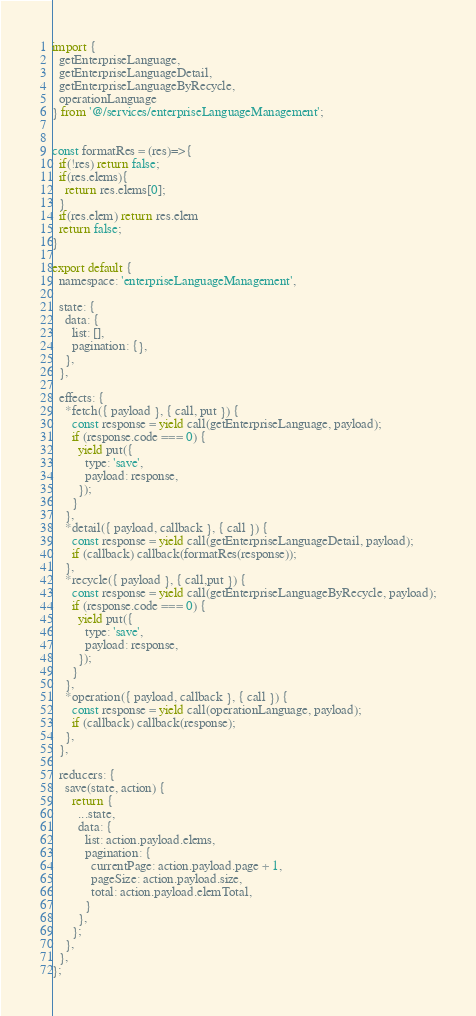<code> <loc_0><loc_0><loc_500><loc_500><_JavaScript_>import {
  getEnterpriseLanguage,
  getEnterpriseLanguageDetail,
  getEnterpriseLanguageByRecycle,
  operationLanguage
} from '@/services/enterpriseLanguageManagement';


const formatRes = (res)=>{
  if(!res) return false;
  if(res.elems){
    return res.elems[0];
  }
  if(res.elem) return res.elem
  return false;
}

export default {
  namespace: 'enterpriseLanguageManagement',

  state: {
    data: {
      list: [],
      pagination: {},
    },
  },

  effects: {
    *fetch({ payload }, { call, put }) {
      const response = yield call(getEnterpriseLanguage, payload);
      if (response.code === 0) {
        yield put({
          type: 'save',
          payload: response,
        });
      }
    },
    *detail({ payload, callback }, { call }) {
      const response = yield call(getEnterpriseLanguageDetail, payload);
      if (callback) callback(formatRes(response));
    },
    *recycle({ payload }, { call,put }) {
      const response = yield call(getEnterpriseLanguageByRecycle, payload);
      if (response.code === 0) {
        yield put({
          type: 'save',
          payload: response,
        });
      }
    },
    *operation({ payload, callback }, { call }) {
      const response = yield call(operationLanguage, payload);
      if (callback) callback(response);
    },
  },

  reducers: {
    save(state, action) {
      return {
        ...state,
        data: {
          list: action.payload.elems,
          pagination: {
            currentPage: action.payload.page + 1,
            pageSize: action.payload.size,
            total: action.payload.elemTotal,
          }
        },
      };
    },
  },
};
</code> 